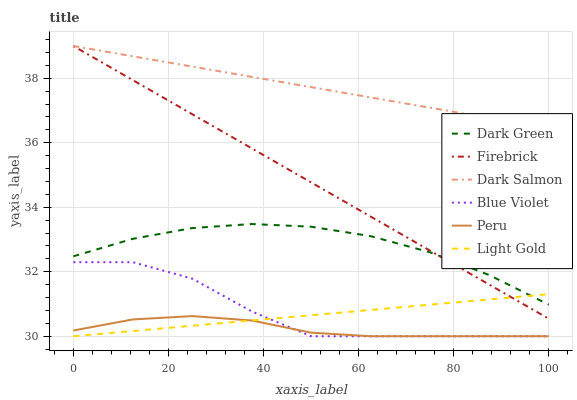Does Peru have the minimum area under the curve?
Answer yes or no. Yes. Does Dark Salmon have the maximum area under the curve?
Answer yes or no. Yes. Does Dark Salmon have the minimum area under the curve?
Answer yes or no. No. Does Peru have the maximum area under the curve?
Answer yes or no. No. Is Light Gold the smoothest?
Answer yes or no. Yes. Is Blue Violet the roughest?
Answer yes or no. Yes. Is Dark Salmon the smoothest?
Answer yes or no. No. Is Dark Salmon the roughest?
Answer yes or no. No. Does Peru have the lowest value?
Answer yes or no. Yes. Does Dark Salmon have the lowest value?
Answer yes or no. No. Does Dark Salmon have the highest value?
Answer yes or no. Yes. Does Peru have the highest value?
Answer yes or no. No. Is Dark Green less than Dark Salmon?
Answer yes or no. Yes. Is Dark Salmon greater than Blue Violet?
Answer yes or no. Yes. Does Dark Green intersect Firebrick?
Answer yes or no. Yes. Is Dark Green less than Firebrick?
Answer yes or no. No. Is Dark Green greater than Firebrick?
Answer yes or no. No. Does Dark Green intersect Dark Salmon?
Answer yes or no. No. 